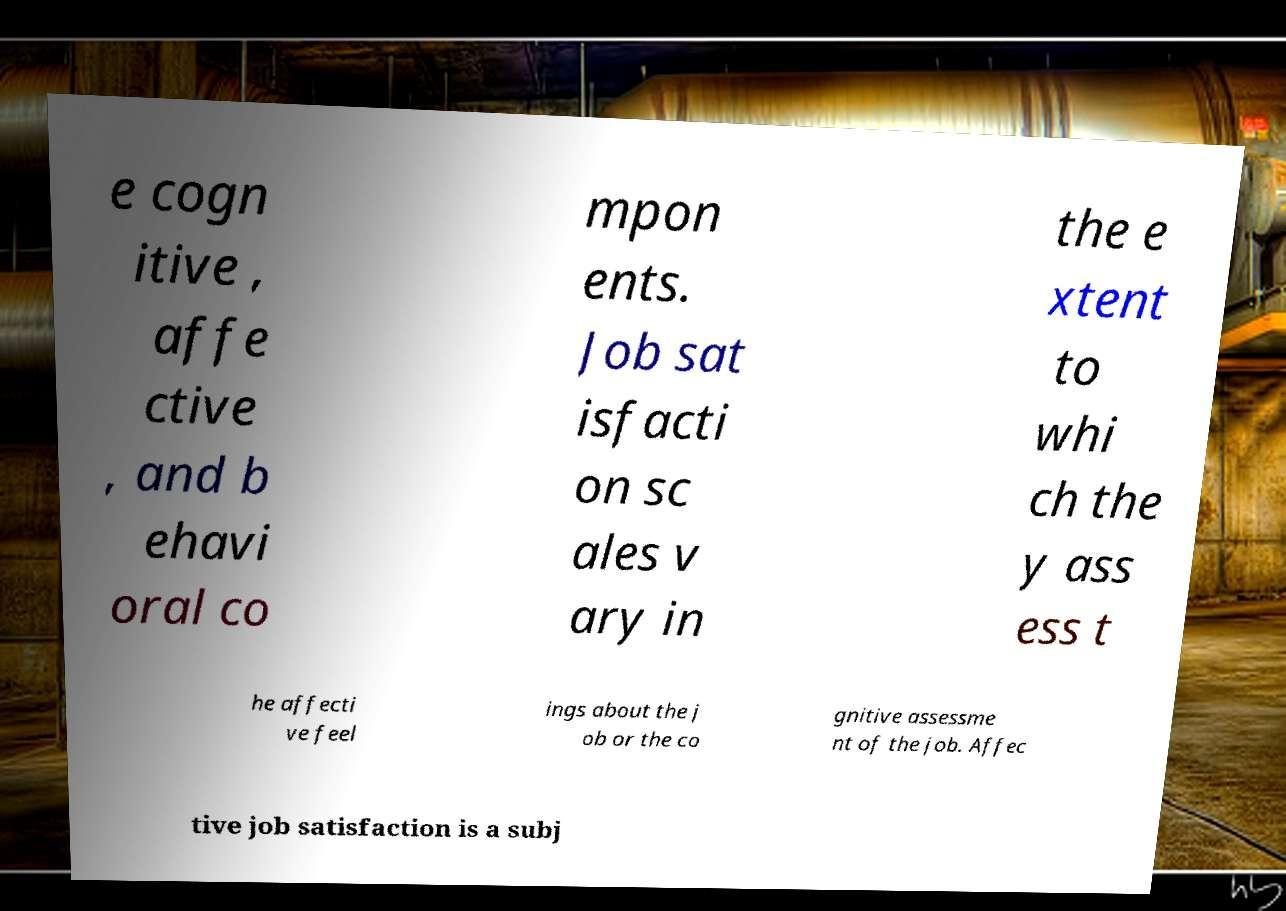Could you extract and type out the text from this image? e cogn itive , affe ctive , and b ehavi oral co mpon ents. Job sat isfacti on sc ales v ary in the e xtent to whi ch the y ass ess t he affecti ve feel ings about the j ob or the co gnitive assessme nt of the job. Affec tive job satisfaction is a subj 